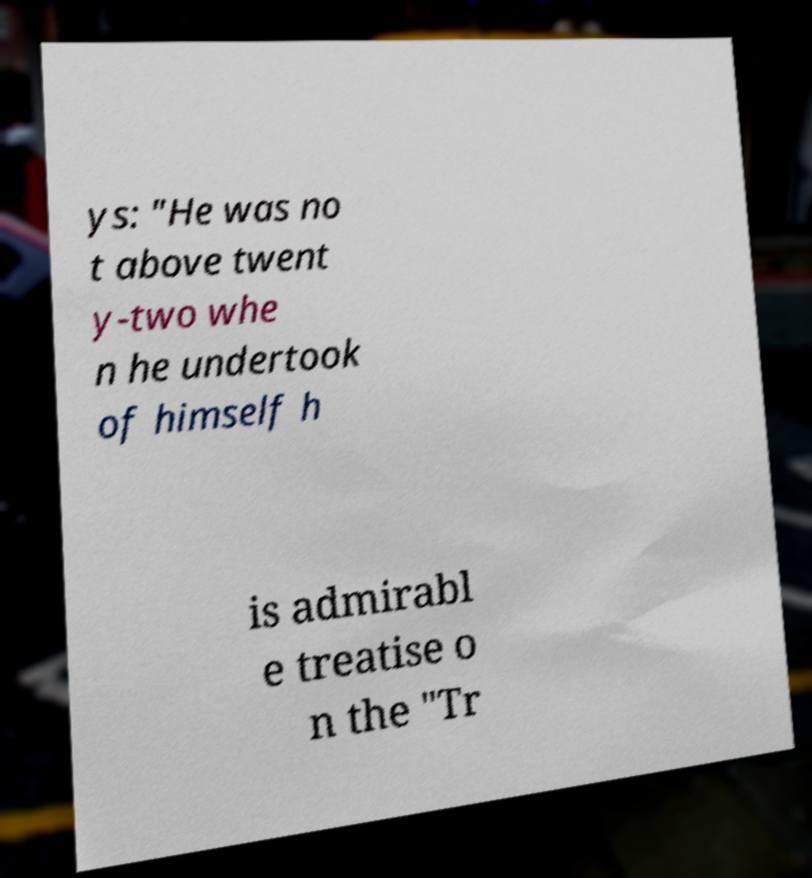Could you assist in decoding the text presented in this image and type it out clearly? ys: "He was no t above twent y-two whe n he undertook of himself h is admirabl e treatise o n the "Tr 